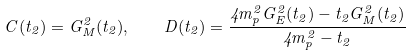Convert formula to latex. <formula><loc_0><loc_0><loc_500><loc_500>C ( t _ { 2 } ) = G _ { M } ^ { 2 } ( t _ { 2 } ) , \quad D ( t _ { 2 } ) = \frac { 4 m _ { p } ^ { 2 } G _ { E } ^ { 2 } ( t _ { 2 } ) - t _ { 2 } G _ { M } ^ { 2 } ( t _ { 2 } ) } { 4 m _ { p } ^ { 2 } - t _ { 2 } }</formula> 